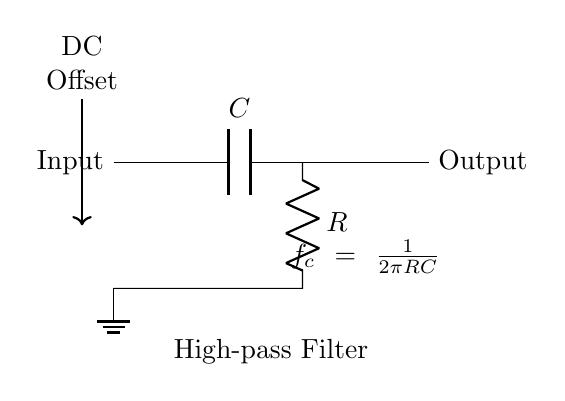What is the function of the capacitor in this high-pass filter? The capacitor blocks DC signals, allowing AC signals to pass through. This is the primary function of the capacitor in a high-pass filter configuration.
Answer: Blocks DC What is the cutoff frequency formula shown in the circuit? The cutoff frequency formula is derived from the relationship between the resistor and capacitor values. It is given as fc = 1/(2πRC), showing how these components determine the frequency at which signals are allowed to pass through.
Answer: fc = 1/(2πRC) How many main components are in this circuit? The circuit consists of two main components: a capacitor and a resistor. This count focuses on the essential elements that define the high-pass filter.
Answer: Two What happens to the DC offset in this circuit? The DC offset is removed as it is blocked by the capacitor, ensuring that only AC signals are present at the output. This is crucial for accurately monitoring patient signals in medical applications.
Answer: Removed What type of filter is represented by this circuit? This circuit represents a high-pass filter, which is designed to allow higher frequency signals while eliminating lower frequencies, including DC offsets.
Answer: High-pass filter What is the direction of current flow in this high-pass filter? Current flows from the input, through the capacitor and the resistor, towards the output. The flow is sequential, moving from one component to the next.
Answer: From input to output 